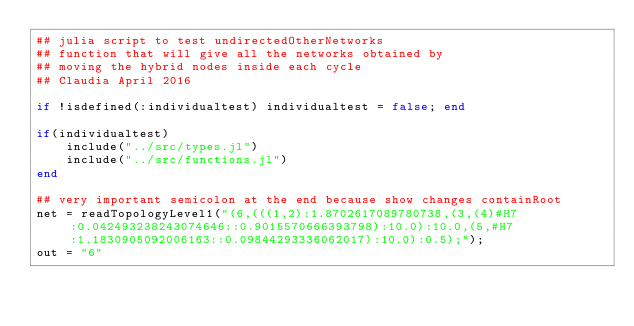<code> <loc_0><loc_0><loc_500><loc_500><_Julia_>## julia script to test undirectedOtherNetworks
## function that will give all the networks obtained by
## moving the hybrid nodes inside each cycle
## Claudia April 2016

if !isdefined(:individualtest) individualtest = false; end

if(individualtest)
    include("../src/types.jl")
    include("../src/functions.jl")
end

## very important semicolon at the end because show changes containRoot
net = readTopologyLevel1("(6,(((1,2):1.8702617089780738,(3,(4)#H7:0.042493238243074646::0.9015570666393798):10.0):10.0,(5,#H7:1.1830905092006163::0.09844293336062017):10.0):0.5);");
out = "6"</code> 